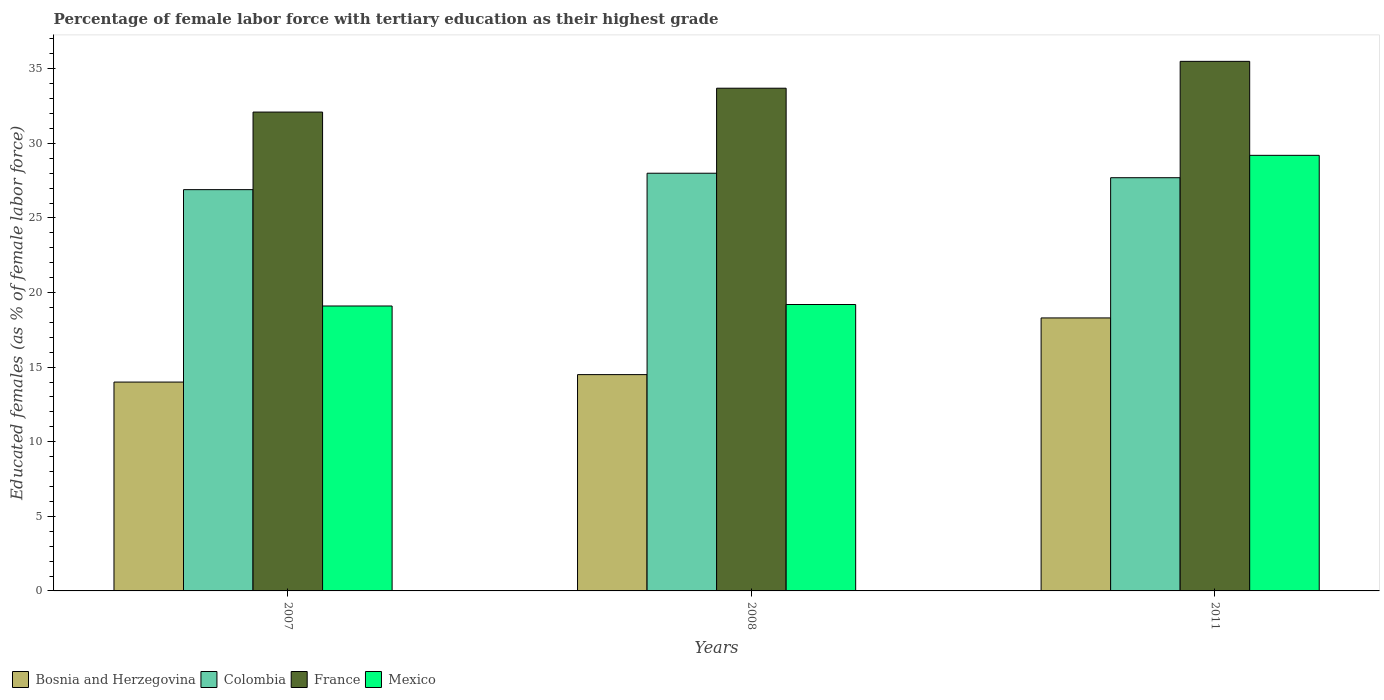How many groups of bars are there?
Make the answer very short. 3. Are the number of bars on each tick of the X-axis equal?
Your answer should be very brief. Yes. In how many cases, is the number of bars for a given year not equal to the number of legend labels?
Your answer should be very brief. 0. What is the percentage of female labor force with tertiary education in Colombia in 2011?
Provide a short and direct response. 27.7. Across all years, what is the maximum percentage of female labor force with tertiary education in Mexico?
Your answer should be compact. 29.2. Across all years, what is the minimum percentage of female labor force with tertiary education in France?
Provide a short and direct response. 32.1. In which year was the percentage of female labor force with tertiary education in Colombia minimum?
Make the answer very short. 2007. What is the total percentage of female labor force with tertiary education in France in the graph?
Your answer should be compact. 101.3. What is the difference between the percentage of female labor force with tertiary education in Colombia in 2007 and that in 2011?
Your answer should be very brief. -0.8. What is the average percentage of female labor force with tertiary education in Colombia per year?
Ensure brevity in your answer.  27.53. In the year 2011, what is the difference between the percentage of female labor force with tertiary education in Bosnia and Herzegovina and percentage of female labor force with tertiary education in Mexico?
Offer a very short reply. -10.9. What is the ratio of the percentage of female labor force with tertiary education in France in 2008 to that in 2011?
Offer a very short reply. 0.95. Is the percentage of female labor force with tertiary education in Colombia in 2007 less than that in 2011?
Make the answer very short. Yes. What is the difference between the highest and the second highest percentage of female labor force with tertiary education in Mexico?
Offer a terse response. 10. What is the difference between the highest and the lowest percentage of female labor force with tertiary education in Bosnia and Herzegovina?
Your answer should be very brief. 4.3. In how many years, is the percentage of female labor force with tertiary education in Colombia greater than the average percentage of female labor force with tertiary education in Colombia taken over all years?
Keep it short and to the point. 2. What does the 3rd bar from the right in 2008 represents?
Offer a terse response. Colombia. Are the values on the major ticks of Y-axis written in scientific E-notation?
Your response must be concise. No. Does the graph contain grids?
Ensure brevity in your answer.  No. Where does the legend appear in the graph?
Ensure brevity in your answer.  Bottom left. How many legend labels are there?
Your response must be concise. 4. What is the title of the graph?
Offer a very short reply. Percentage of female labor force with tertiary education as their highest grade. What is the label or title of the Y-axis?
Your answer should be very brief. Educated females (as % of female labor force). What is the Educated females (as % of female labor force) in Bosnia and Herzegovina in 2007?
Keep it short and to the point. 14. What is the Educated females (as % of female labor force) in Colombia in 2007?
Your answer should be compact. 26.9. What is the Educated females (as % of female labor force) of France in 2007?
Provide a short and direct response. 32.1. What is the Educated females (as % of female labor force) in Mexico in 2007?
Keep it short and to the point. 19.1. What is the Educated females (as % of female labor force) in France in 2008?
Make the answer very short. 33.7. What is the Educated females (as % of female labor force) in Mexico in 2008?
Ensure brevity in your answer.  19.2. What is the Educated females (as % of female labor force) in Bosnia and Herzegovina in 2011?
Make the answer very short. 18.3. What is the Educated females (as % of female labor force) of Colombia in 2011?
Make the answer very short. 27.7. What is the Educated females (as % of female labor force) in France in 2011?
Offer a terse response. 35.5. What is the Educated females (as % of female labor force) of Mexico in 2011?
Your answer should be very brief. 29.2. Across all years, what is the maximum Educated females (as % of female labor force) of Bosnia and Herzegovina?
Provide a short and direct response. 18.3. Across all years, what is the maximum Educated females (as % of female labor force) in Colombia?
Make the answer very short. 28. Across all years, what is the maximum Educated females (as % of female labor force) of France?
Give a very brief answer. 35.5. Across all years, what is the maximum Educated females (as % of female labor force) of Mexico?
Provide a short and direct response. 29.2. Across all years, what is the minimum Educated females (as % of female labor force) of Colombia?
Offer a very short reply. 26.9. Across all years, what is the minimum Educated females (as % of female labor force) in France?
Offer a very short reply. 32.1. Across all years, what is the minimum Educated females (as % of female labor force) in Mexico?
Ensure brevity in your answer.  19.1. What is the total Educated females (as % of female labor force) in Bosnia and Herzegovina in the graph?
Provide a succinct answer. 46.8. What is the total Educated females (as % of female labor force) of Colombia in the graph?
Provide a short and direct response. 82.6. What is the total Educated females (as % of female labor force) in France in the graph?
Offer a terse response. 101.3. What is the total Educated females (as % of female labor force) in Mexico in the graph?
Your response must be concise. 67.5. What is the difference between the Educated females (as % of female labor force) of France in 2007 and that in 2008?
Provide a short and direct response. -1.6. What is the difference between the Educated females (as % of female labor force) of Mexico in 2007 and that in 2008?
Make the answer very short. -0.1. What is the difference between the Educated females (as % of female labor force) in Bosnia and Herzegovina in 2007 and that in 2011?
Ensure brevity in your answer.  -4.3. What is the difference between the Educated females (as % of female labor force) of Colombia in 2007 and that in 2011?
Keep it short and to the point. -0.8. What is the difference between the Educated females (as % of female labor force) in Mexico in 2007 and that in 2011?
Your answer should be compact. -10.1. What is the difference between the Educated females (as % of female labor force) in Bosnia and Herzegovina in 2008 and that in 2011?
Keep it short and to the point. -3.8. What is the difference between the Educated females (as % of female labor force) in Colombia in 2008 and that in 2011?
Give a very brief answer. 0.3. What is the difference between the Educated females (as % of female labor force) in France in 2008 and that in 2011?
Make the answer very short. -1.8. What is the difference between the Educated females (as % of female labor force) of Mexico in 2008 and that in 2011?
Keep it short and to the point. -10. What is the difference between the Educated females (as % of female labor force) of Bosnia and Herzegovina in 2007 and the Educated females (as % of female labor force) of Colombia in 2008?
Your answer should be very brief. -14. What is the difference between the Educated females (as % of female labor force) in Bosnia and Herzegovina in 2007 and the Educated females (as % of female labor force) in France in 2008?
Give a very brief answer. -19.7. What is the difference between the Educated females (as % of female labor force) of Bosnia and Herzegovina in 2007 and the Educated females (as % of female labor force) of Mexico in 2008?
Your response must be concise. -5.2. What is the difference between the Educated females (as % of female labor force) of Colombia in 2007 and the Educated females (as % of female labor force) of Mexico in 2008?
Give a very brief answer. 7.7. What is the difference between the Educated females (as % of female labor force) in Bosnia and Herzegovina in 2007 and the Educated females (as % of female labor force) in Colombia in 2011?
Your answer should be compact. -13.7. What is the difference between the Educated females (as % of female labor force) of Bosnia and Herzegovina in 2007 and the Educated females (as % of female labor force) of France in 2011?
Ensure brevity in your answer.  -21.5. What is the difference between the Educated females (as % of female labor force) of Bosnia and Herzegovina in 2007 and the Educated females (as % of female labor force) of Mexico in 2011?
Your answer should be compact. -15.2. What is the difference between the Educated females (as % of female labor force) in Colombia in 2007 and the Educated females (as % of female labor force) in France in 2011?
Your answer should be very brief. -8.6. What is the difference between the Educated females (as % of female labor force) of Colombia in 2007 and the Educated females (as % of female labor force) of Mexico in 2011?
Your answer should be very brief. -2.3. What is the difference between the Educated females (as % of female labor force) of France in 2007 and the Educated females (as % of female labor force) of Mexico in 2011?
Offer a very short reply. 2.9. What is the difference between the Educated females (as % of female labor force) in Bosnia and Herzegovina in 2008 and the Educated females (as % of female labor force) in Mexico in 2011?
Offer a terse response. -14.7. What is the difference between the Educated females (as % of female labor force) in Colombia in 2008 and the Educated females (as % of female labor force) in France in 2011?
Keep it short and to the point. -7.5. What is the average Educated females (as % of female labor force) of Bosnia and Herzegovina per year?
Your response must be concise. 15.6. What is the average Educated females (as % of female labor force) of Colombia per year?
Offer a terse response. 27.53. What is the average Educated females (as % of female labor force) of France per year?
Ensure brevity in your answer.  33.77. What is the average Educated females (as % of female labor force) in Mexico per year?
Give a very brief answer. 22.5. In the year 2007, what is the difference between the Educated females (as % of female labor force) of Bosnia and Herzegovina and Educated females (as % of female labor force) of Colombia?
Offer a very short reply. -12.9. In the year 2007, what is the difference between the Educated females (as % of female labor force) of Bosnia and Herzegovina and Educated females (as % of female labor force) of France?
Provide a succinct answer. -18.1. In the year 2007, what is the difference between the Educated females (as % of female labor force) in Bosnia and Herzegovina and Educated females (as % of female labor force) in Mexico?
Offer a very short reply. -5.1. In the year 2007, what is the difference between the Educated females (as % of female labor force) in France and Educated females (as % of female labor force) in Mexico?
Keep it short and to the point. 13. In the year 2008, what is the difference between the Educated females (as % of female labor force) in Bosnia and Herzegovina and Educated females (as % of female labor force) in Colombia?
Your answer should be very brief. -13.5. In the year 2008, what is the difference between the Educated females (as % of female labor force) in Bosnia and Herzegovina and Educated females (as % of female labor force) in France?
Ensure brevity in your answer.  -19.2. In the year 2008, what is the difference between the Educated females (as % of female labor force) in Colombia and Educated females (as % of female labor force) in France?
Offer a very short reply. -5.7. In the year 2008, what is the difference between the Educated females (as % of female labor force) in France and Educated females (as % of female labor force) in Mexico?
Offer a terse response. 14.5. In the year 2011, what is the difference between the Educated females (as % of female labor force) of Bosnia and Herzegovina and Educated females (as % of female labor force) of France?
Make the answer very short. -17.2. In the year 2011, what is the difference between the Educated females (as % of female labor force) of Colombia and Educated females (as % of female labor force) of Mexico?
Give a very brief answer. -1.5. What is the ratio of the Educated females (as % of female labor force) in Bosnia and Herzegovina in 2007 to that in 2008?
Your answer should be very brief. 0.97. What is the ratio of the Educated females (as % of female labor force) of Colombia in 2007 to that in 2008?
Your answer should be compact. 0.96. What is the ratio of the Educated females (as % of female labor force) in France in 2007 to that in 2008?
Ensure brevity in your answer.  0.95. What is the ratio of the Educated females (as % of female labor force) in Mexico in 2007 to that in 2008?
Your answer should be very brief. 0.99. What is the ratio of the Educated females (as % of female labor force) in Bosnia and Herzegovina in 2007 to that in 2011?
Your answer should be very brief. 0.77. What is the ratio of the Educated females (as % of female labor force) of Colombia in 2007 to that in 2011?
Keep it short and to the point. 0.97. What is the ratio of the Educated females (as % of female labor force) of France in 2007 to that in 2011?
Keep it short and to the point. 0.9. What is the ratio of the Educated females (as % of female labor force) of Mexico in 2007 to that in 2011?
Make the answer very short. 0.65. What is the ratio of the Educated females (as % of female labor force) of Bosnia and Herzegovina in 2008 to that in 2011?
Your response must be concise. 0.79. What is the ratio of the Educated females (as % of female labor force) of Colombia in 2008 to that in 2011?
Offer a very short reply. 1.01. What is the ratio of the Educated females (as % of female labor force) in France in 2008 to that in 2011?
Provide a succinct answer. 0.95. What is the ratio of the Educated females (as % of female labor force) in Mexico in 2008 to that in 2011?
Provide a short and direct response. 0.66. What is the difference between the highest and the second highest Educated females (as % of female labor force) in Bosnia and Herzegovina?
Ensure brevity in your answer.  3.8. What is the difference between the highest and the second highest Educated females (as % of female labor force) in Mexico?
Offer a terse response. 10. What is the difference between the highest and the lowest Educated females (as % of female labor force) in Mexico?
Ensure brevity in your answer.  10.1. 